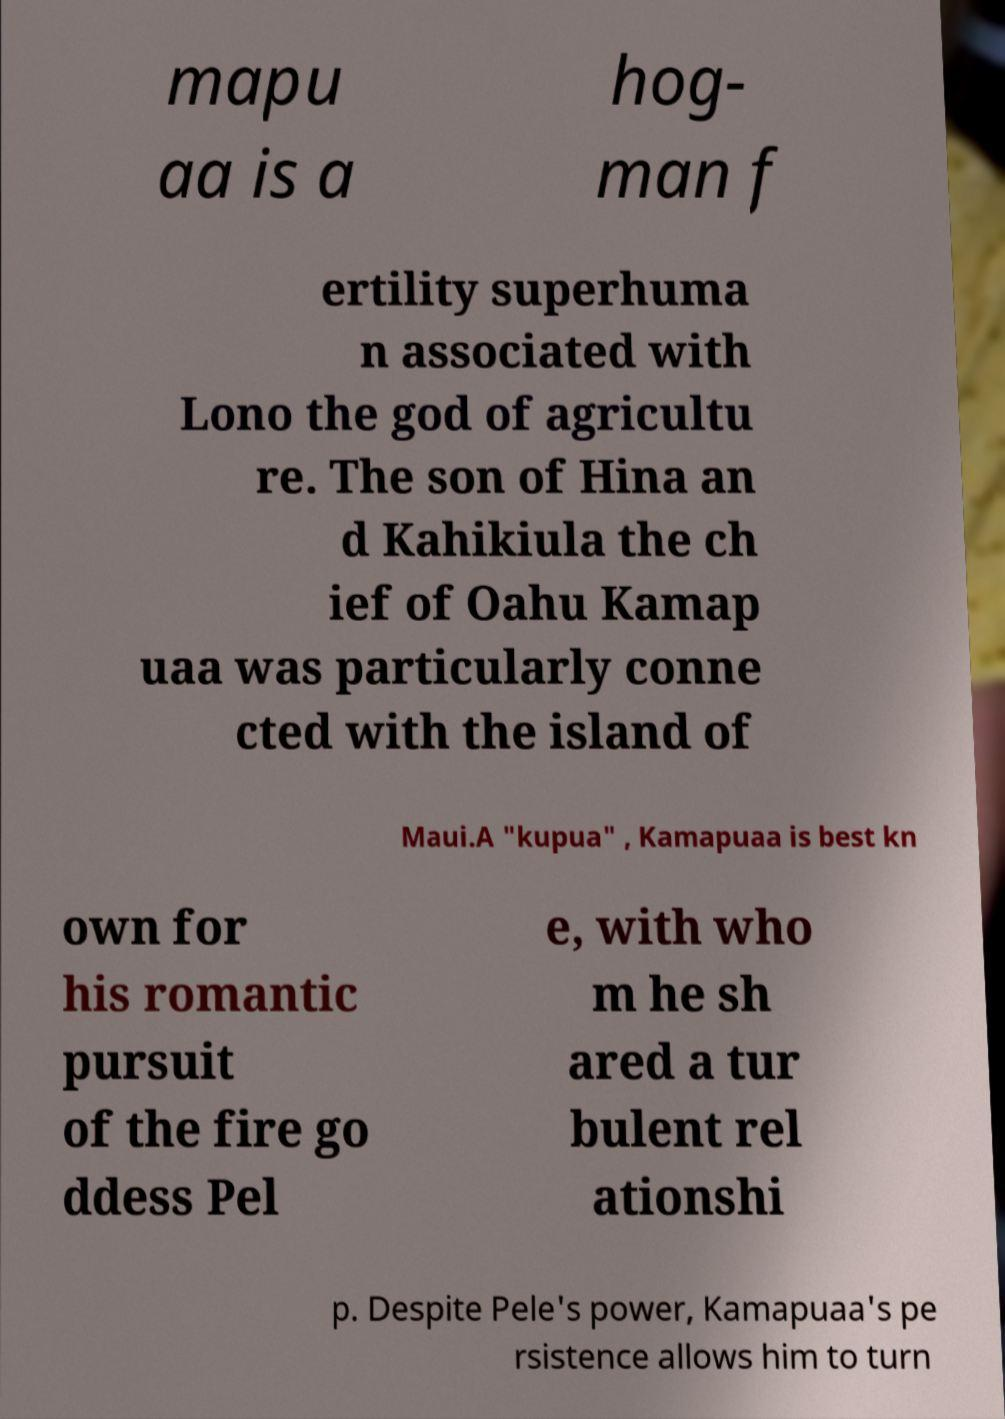Could you extract and type out the text from this image? mapu aa is a hog- man f ertility superhuma n associated with Lono the god of agricultu re. The son of Hina an d Kahikiula the ch ief of Oahu Kamap uaa was particularly conne cted with the island of Maui.A "kupua" , Kamapuaa is best kn own for his romantic pursuit of the fire go ddess Pel e, with who m he sh ared a tur bulent rel ationshi p. Despite Pele's power, Kamapuaa's pe rsistence allows him to turn 